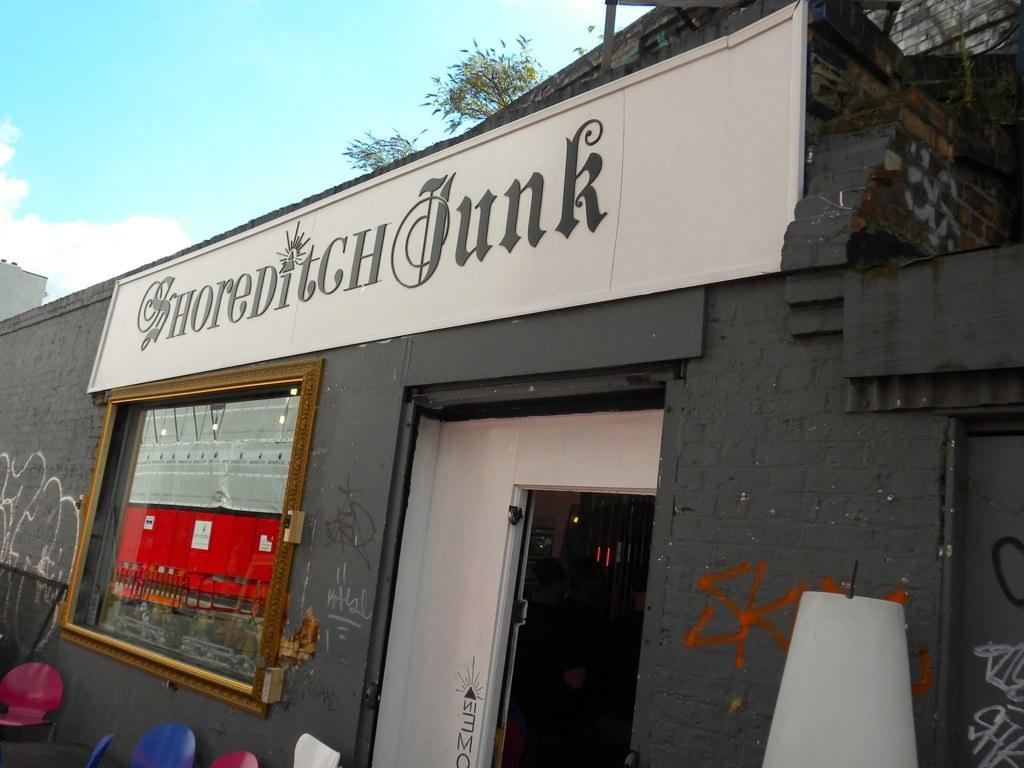What type of establishment is shown in the image? There is a restaurant in the image. What architectural features can be seen on the building? There is a door and a window in the image. What is visible at the top of the image? The sky is visible at the top of the image. What type of bulb is used to light up the restaurant in the image? There is no information about the type of bulb used in the restaurant in the image. Is eggnog being served at the restaurant in the image? There is no information about the menu or what is being served at the restaurant in the image. 